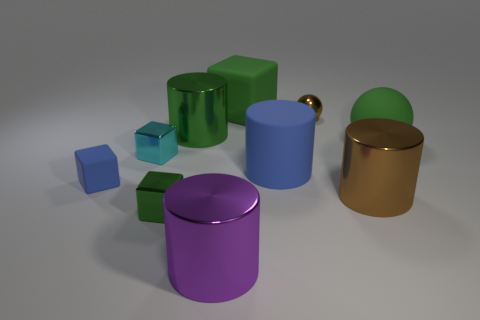Is there a small purple block that has the same material as the purple cylinder?
Ensure brevity in your answer.  No. What shape is the small metallic thing that is right of the tiny green cube that is to the left of the brown shiny thing in front of the big ball?
Offer a terse response. Sphere. Does the cyan shiny block have the same size as the brown metallic thing in front of the large rubber ball?
Provide a short and direct response. No. There is a metallic thing that is in front of the blue cylinder and to the left of the purple object; what is its shape?
Give a very brief answer. Cube. How many tiny objects are either yellow matte spheres or shiny cubes?
Your response must be concise. 2. Is the number of large purple shiny objects that are behind the purple cylinder the same as the number of big green cylinders that are in front of the large blue object?
Provide a short and direct response. Yes. How many other objects are the same color as the big rubber ball?
Provide a short and direct response. 3. Is the number of big cylinders on the left side of the large brown metallic thing the same as the number of purple rubber cylinders?
Ensure brevity in your answer.  No. Is the brown ball the same size as the purple thing?
Your answer should be very brief. No. What is the cube that is both in front of the tiny cyan metallic thing and behind the large brown cylinder made of?
Offer a terse response. Rubber. 